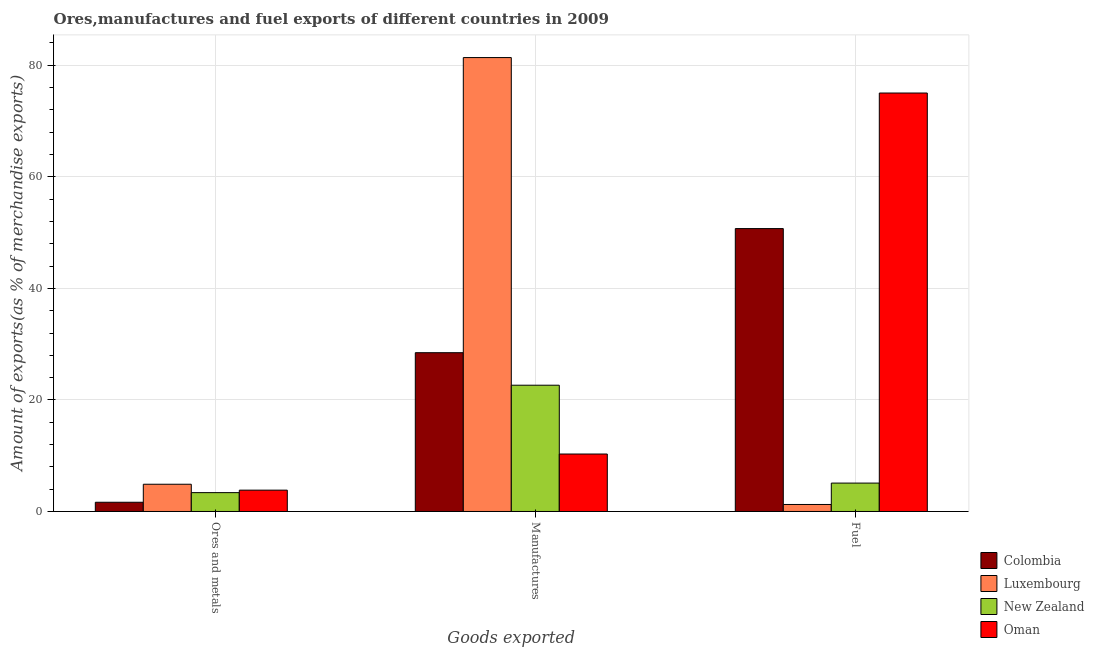How many different coloured bars are there?
Your response must be concise. 4. How many bars are there on the 3rd tick from the left?
Keep it short and to the point. 4. What is the label of the 1st group of bars from the left?
Your answer should be compact. Ores and metals. What is the percentage of ores and metals exports in Oman?
Offer a terse response. 3.83. Across all countries, what is the maximum percentage of manufactures exports?
Give a very brief answer. 81.38. Across all countries, what is the minimum percentage of fuel exports?
Your answer should be very brief. 1.26. In which country was the percentage of fuel exports maximum?
Ensure brevity in your answer.  Oman. In which country was the percentage of manufactures exports minimum?
Your answer should be very brief. Oman. What is the total percentage of manufactures exports in the graph?
Keep it short and to the point. 142.79. What is the difference between the percentage of ores and metals exports in New Zealand and that in Oman?
Your answer should be very brief. -0.45. What is the difference between the percentage of manufactures exports in New Zealand and the percentage of fuel exports in Oman?
Your answer should be very brief. -52.39. What is the average percentage of ores and metals exports per country?
Offer a very short reply. 3.44. What is the difference between the percentage of manufactures exports and percentage of ores and metals exports in Oman?
Provide a short and direct response. 6.48. In how many countries, is the percentage of manufactures exports greater than 24 %?
Your answer should be compact. 2. What is the ratio of the percentage of ores and metals exports in New Zealand to that in Oman?
Offer a terse response. 0.88. Is the difference between the percentage of ores and metals exports in New Zealand and Luxembourg greater than the difference between the percentage of fuel exports in New Zealand and Luxembourg?
Your response must be concise. No. What is the difference between the highest and the second highest percentage of fuel exports?
Provide a short and direct response. 24.3. What is the difference between the highest and the lowest percentage of fuel exports?
Your answer should be compact. 73.77. In how many countries, is the percentage of ores and metals exports greater than the average percentage of ores and metals exports taken over all countries?
Your answer should be very brief. 2. What does the 4th bar from the left in Fuel represents?
Provide a succinct answer. Oman. What does the 2nd bar from the right in Fuel represents?
Make the answer very short. New Zealand. Is it the case that in every country, the sum of the percentage of ores and metals exports and percentage of manufactures exports is greater than the percentage of fuel exports?
Offer a terse response. No. Are all the bars in the graph horizontal?
Keep it short and to the point. No. How many countries are there in the graph?
Offer a terse response. 4. What is the difference between two consecutive major ticks on the Y-axis?
Provide a succinct answer. 20. Are the values on the major ticks of Y-axis written in scientific E-notation?
Provide a succinct answer. No. Does the graph contain any zero values?
Your answer should be very brief. No. Does the graph contain grids?
Provide a short and direct response. Yes. How many legend labels are there?
Your answer should be very brief. 4. How are the legend labels stacked?
Your response must be concise. Vertical. What is the title of the graph?
Give a very brief answer. Ores,manufactures and fuel exports of different countries in 2009. Does "Mauritius" appear as one of the legend labels in the graph?
Your answer should be compact. No. What is the label or title of the X-axis?
Provide a succinct answer. Goods exported. What is the label or title of the Y-axis?
Ensure brevity in your answer.  Amount of exports(as % of merchandise exports). What is the Amount of exports(as % of merchandise exports) in Colombia in Ores and metals?
Offer a very short reply. 1.65. What is the Amount of exports(as % of merchandise exports) of Luxembourg in Ores and metals?
Your answer should be compact. 4.88. What is the Amount of exports(as % of merchandise exports) in New Zealand in Ores and metals?
Offer a terse response. 3.38. What is the Amount of exports(as % of merchandise exports) of Oman in Ores and metals?
Offer a very short reply. 3.83. What is the Amount of exports(as % of merchandise exports) of Colombia in Manufactures?
Your answer should be very brief. 28.47. What is the Amount of exports(as % of merchandise exports) of Luxembourg in Manufactures?
Your answer should be very brief. 81.38. What is the Amount of exports(as % of merchandise exports) of New Zealand in Manufactures?
Your answer should be very brief. 22.64. What is the Amount of exports(as % of merchandise exports) of Oman in Manufactures?
Your answer should be compact. 10.3. What is the Amount of exports(as % of merchandise exports) in Colombia in Fuel?
Offer a terse response. 50.72. What is the Amount of exports(as % of merchandise exports) of Luxembourg in Fuel?
Ensure brevity in your answer.  1.26. What is the Amount of exports(as % of merchandise exports) of New Zealand in Fuel?
Offer a very short reply. 5.09. What is the Amount of exports(as % of merchandise exports) of Oman in Fuel?
Provide a succinct answer. 75.03. Across all Goods exported, what is the maximum Amount of exports(as % of merchandise exports) in Colombia?
Your answer should be compact. 50.72. Across all Goods exported, what is the maximum Amount of exports(as % of merchandise exports) of Luxembourg?
Your response must be concise. 81.38. Across all Goods exported, what is the maximum Amount of exports(as % of merchandise exports) of New Zealand?
Keep it short and to the point. 22.64. Across all Goods exported, what is the maximum Amount of exports(as % of merchandise exports) of Oman?
Your response must be concise. 75.03. Across all Goods exported, what is the minimum Amount of exports(as % of merchandise exports) in Colombia?
Your answer should be very brief. 1.65. Across all Goods exported, what is the minimum Amount of exports(as % of merchandise exports) in Luxembourg?
Offer a terse response. 1.26. Across all Goods exported, what is the minimum Amount of exports(as % of merchandise exports) in New Zealand?
Keep it short and to the point. 3.38. Across all Goods exported, what is the minimum Amount of exports(as % of merchandise exports) in Oman?
Your response must be concise. 3.83. What is the total Amount of exports(as % of merchandise exports) of Colombia in the graph?
Provide a short and direct response. 80.84. What is the total Amount of exports(as % of merchandise exports) of Luxembourg in the graph?
Your answer should be compact. 87.52. What is the total Amount of exports(as % of merchandise exports) in New Zealand in the graph?
Provide a short and direct response. 31.11. What is the total Amount of exports(as % of merchandise exports) in Oman in the graph?
Ensure brevity in your answer.  89.15. What is the difference between the Amount of exports(as % of merchandise exports) of Colombia in Ores and metals and that in Manufactures?
Provide a short and direct response. -26.82. What is the difference between the Amount of exports(as % of merchandise exports) in Luxembourg in Ores and metals and that in Manufactures?
Ensure brevity in your answer.  -76.5. What is the difference between the Amount of exports(as % of merchandise exports) in New Zealand in Ores and metals and that in Manufactures?
Your response must be concise. -19.26. What is the difference between the Amount of exports(as % of merchandise exports) of Oman in Ores and metals and that in Manufactures?
Make the answer very short. -6.48. What is the difference between the Amount of exports(as % of merchandise exports) in Colombia in Ores and metals and that in Fuel?
Your response must be concise. -49.07. What is the difference between the Amount of exports(as % of merchandise exports) in Luxembourg in Ores and metals and that in Fuel?
Your answer should be very brief. 3.63. What is the difference between the Amount of exports(as % of merchandise exports) in New Zealand in Ores and metals and that in Fuel?
Ensure brevity in your answer.  -1.71. What is the difference between the Amount of exports(as % of merchandise exports) of Oman in Ores and metals and that in Fuel?
Offer a terse response. -71.2. What is the difference between the Amount of exports(as % of merchandise exports) in Colombia in Manufactures and that in Fuel?
Your response must be concise. -22.25. What is the difference between the Amount of exports(as % of merchandise exports) in Luxembourg in Manufactures and that in Fuel?
Give a very brief answer. 80.13. What is the difference between the Amount of exports(as % of merchandise exports) in New Zealand in Manufactures and that in Fuel?
Your answer should be compact. 17.55. What is the difference between the Amount of exports(as % of merchandise exports) of Oman in Manufactures and that in Fuel?
Provide a succinct answer. -64.72. What is the difference between the Amount of exports(as % of merchandise exports) of Colombia in Ores and metals and the Amount of exports(as % of merchandise exports) of Luxembourg in Manufactures?
Offer a very short reply. -79.73. What is the difference between the Amount of exports(as % of merchandise exports) in Colombia in Ores and metals and the Amount of exports(as % of merchandise exports) in New Zealand in Manufactures?
Provide a succinct answer. -20.99. What is the difference between the Amount of exports(as % of merchandise exports) in Colombia in Ores and metals and the Amount of exports(as % of merchandise exports) in Oman in Manufactures?
Ensure brevity in your answer.  -8.65. What is the difference between the Amount of exports(as % of merchandise exports) of Luxembourg in Ores and metals and the Amount of exports(as % of merchandise exports) of New Zealand in Manufactures?
Provide a succinct answer. -17.76. What is the difference between the Amount of exports(as % of merchandise exports) in Luxembourg in Ores and metals and the Amount of exports(as % of merchandise exports) in Oman in Manufactures?
Make the answer very short. -5.42. What is the difference between the Amount of exports(as % of merchandise exports) in New Zealand in Ores and metals and the Amount of exports(as % of merchandise exports) in Oman in Manufactures?
Your response must be concise. -6.92. What is the difference between the Amount of exports(as % of merchandise exports) in Colombia in Ores and metals and the Amount of exports(as % of merchandise exports) in Luxembourg in Fuel?
Make the answer very short. 0.4. What is the difference between the Amount of exports(as % of merchandise exports) in Colombia in Ores and metals and the Amount of exports(as % of merchandise exports) in New Zealand in Fuel?
Give a very brief answer. -3.44. What is the difference between the Amount of exports(as % of merchandise exports) in Colombia in Ores and metals and the Amount of exports(as % of merchandise exports) in Oman in Fuel?
Your answer should be very brief. -73.37. What is the difference between the Amount of exports(as % of merchandise exports) in Luxembourg in Ores and metals and the Amount of exports(as % of merchandise exports) in New Zealand in Fuel?
Your answer should be compact. -0.21. What is the difference between the Amount of exports(as % of merchandise exports) of Luxembourg in Ores and metals and the Amount of exports(as % of merchandise exports) of Oman in Fuel?
Your answer should be compact. -70.14. What is the difference between the Amount of exports(as % of merchandise exports) of New Zealand in Ores and metals and the Amount of exports(as % of merchandise exports) of Oman in Fuel?
Ensure brevity in your answer.  -71.65. What is the difference between the Amount of exports(as % of merchandise exports) in Colombia in Manufactures and the Amount of exports(as % of merchandise exports) in Luxembourg in Fuel?
Your response must be concise. 27.21. What is the difference between the Amount of exports(as % of merchandise exports) of Colombia in Manufactures and the Amount of exports(as % of merchandise exports) of New Zealand in Fuel?
Make the answer very short. 23.38. What is the difference between the Amount of exports(as % of merchandise exports) of Colombia in Manufactures and the Amount of exports(as % of merchandise exports) of Oman in Fuel?
Ensure brevity in your answer.  -46.56. What is the difference between the Amount of exports(as % of merchandise exports) in Luxembourg in Manufactures and the Amount of exports(as % of merchandise exports) in New Zealand in Fuel?
Make the answer very short. 76.29. What is the difference between the Amount of exports(as % of merchandise exports) of Luxembourg in Manufactures and the Amount of exports(as % of merchandise exports) of Oman in Fuel?
Your response must be concise. 6.36. What is the difference between the Amount of exports(as % of merchandise exports) of New Zealand in Manufactures and the Amount of exports(as % of merchandise exports) of Oman in Fuel?
Offer a very short reply. -52.39. What is the average Amount of exports(as % of merchandise exports) in Colombia per Goods exported?
Ensure brevity in your answer.  26.95. What is the average Amount of exports(as % of merchandise exports) in Luxembourg per Goods exported?
Ensure brevity in your answer.  29.17. What is the average Amount of exports(as % of merchandise exports) in New Zealand per Goods exported?
Offer a terse response. 10.37. What is the average Amount of exports(as % of merchandise exports) in Oman per Goods exported?
Your answer should be compact. 29.72. What is the difference between the Amount of exports(as % of merchandise exports) in Colombia and Amount of exports(as % of merchandise exports) in Luxembourg in Ores and metals?
Your answer should be very brief. -3.23. What is the difference between the Amount of exports(as % of merchandise exports) in Colombia and Amount of exports(as % of merchandise exports) in New Zealand in Ores and metals?
Offer a very short reply. -1.73. What is the difference between the Amount of exports(as % of merchandise exports) in Colombia and Amount of exports(as % of merchandise exports) in Oman in Ores and metals?
Your response must be concise. -2.17. What is the difference between the Amount of exports(as % of merchandise exports) of Luxembourg and Amount of exports(as % of merchandise exports) of New Zealand in Ores and metals?
Make the answer very short. 1.5. What is the difference between the Amount of exports(as % of merchandise exports) of Luxembourg and Amount of exports(as % of merchandise exports) of Oman in Ores and metals?
Make the answer very short. 1.06. What is the difference between the Amount of exports(as % of merchandise exports) of New Zealand and Amount of exports(as % of merchandise exports) of Oman in Ores and metals?
Provide a succinct answer. -0.45. What is the difference between the Amount of exports(as % of merchandise exports) in Colombia and Amount of exports(as % of merchandise exports) in Luxembourg in Manufactures?
Offer a terse response. -52.91. What is the difference between the Amount of exports(as % of merchandise exports) in Colombia and Amount of exports(as % of merchandise exports) in New Zealand in Manufactures?
Your answer should be compact. 5.83. What is the difference between the Amount of exports(as % of merchandise exports) in Colombia and Amount of exports(as % of merchandise exports) in Oman in Manufactures?
Your answer should be compact. 18.17. What is the difference between the Amount of exports(as % of merchandise exports) of Luxembourg and Amount of exports(as % of merchandise exports) of New Zealand in Manufactures?
Provide a succinct answer. 58.74. What is the difference between the Amount of exports(as % of merchandise exports) of Luxembourg and Amount of exports(as % of merchandise exports) of Oman in Manufactures?
Provide a short and direct response. 71.08. What is the difference between the Amount of exports(as % of merchandise exports) of New Zealand and Amount of exports(as % of merchandise exports) of Oman in Manufactures?
Make the answer very short. 12.34. What is the difference between the Amount of exports(as % of merchandise exports) in Colombia and Amount of exports(as % of merchandise exports) in Luxembourg in Fuel?
Give a very brief answer. 49.47. What is the difference between the Amount of exports(as % of merchandise exports) in Colombia and Amount of exports(as % of merchandise exports) in New Zealand in Fuel?
Your response must be concise. 45.63. What is the difference between the Amount of exports(as % of merchandise exports) in Colombia and Amount of exports(as % of merchandise exports) in Oman in Fuel?
Make the answer very short. -24.3. What is the difference between the Amount of exports(as % of merchandise exports) in Luxembourg and Amount of exports(as % of merchandise exports) in New Zealand in Fuel?
Make the answer very short. -3.84. What is the difference between the Amount of exports(as % of merchandise exports) in Luxembourg and Amount of exports(as % of merchandise exports) in Oman in Fuel?
Your response must be concise. -73.77. What is the difference between the Amount of exports(as % of merchandise exports) of New Zealand and Amount of exports(as % of merchandise exports) of Oman in Fuel?
Provide a succinct answer. -69.93. What is the ratio of the Amount of exports(as % of merchandise exports) of Colombia in Ores and metals to that in Manufactures?
Offer a terse response. 0.06. What is the ratio of the Amount of exports(as % of merchandise exports) of Luxembourg in Ores and metals to that in Manufactures?
Your response must be concise. 0.06. What is the ratio of the Amount of exports(as % of merchandise exports) in New Zealand in Ores and metals to that in Manufactures?
Provide a succinct answer. 0.15. What is the ratio of the Amount of exports(as % of merchandise exports) in Oman in Ores and metals to that in Manufactures?
Give a very brief answer. 0.37. What is the ratio of the Amount of exports(as % of merchandise exports) of Colombia in Ores and metals to that in Fuel?
Offer a very short reply. 0.03. What is the ratio of the Amount of exports(as % of merchandise exports) in Luxembourg in Ores and metals to that in Fuel?
Make the answer very short. 3.89. What is the ratio of the Amount of exports(as % of merchandise exports) of New Zealand in Ores and metals to that in Fuel?
Your answer should be compact. 0.66. What is the ratio of the Amount of exports(as % of merchandise exports) of Oman in Ores and metals to that in Fuel?
Make the answer very short. 0.05. What is the ratio of the Amount of exports(as % of merchandise exports) of Colombia in Manufactures to that in Fuel?
Your response must be concise. 0.56. What is the ratio of the Amount of exports(as % of merchandise exports) in Luxembourg in Manufactures to that in Fuel?
Give a very brief answer. 64.83. What is the ratio of the Amount of exports(as % of merchandise exports) of New Zealand in Manufactures to that in Fuel?
Provide a succinct answer. 4.45. What is the ratio of the Amount of exports(as % of merchandise exports) of Oman in Manufactures to that in Fuel?
Ensure brevity in your answer.  0.14. What is the difference between the highest and the second highest Amount of exports(as % of merchandise exports) in Colombia?
Make the answer very short. 22.25. What is the difference between the highest and the second highest Amount of exports(as % of merchandise exports) in Luxembourg?
Keep it short and to the point. 76.5. What is the difference between the highest and the second highest Amount of exports(as % of merchandise exports) in New Zealand?
Give a very brief answer. 17.55. What is the difference between the highest and the second highest Amount of exports(as % of merchandise exports) of Oman?
Ensure brevity in your answer.  64.72. What is the difference between the highest and the lowest Amount of exports(as % of merchandise exports) of Colombia?
Your response must be concise. 49.07. What is the difference between the highest and the lowest Amount of exports(as % of merchandise exports) of Luxembourg?
Provide a short and direct response. 80.13. What is the difference between the highest and the lowest Amount of exports(as % of merchandise exports) of New Zealand?
Give a very brief answer. 19.26. What is the difference between the highest and the lowest Amount of exports(as % of merchandise exports) of Oman?
Offer a terse response. 71.2. 